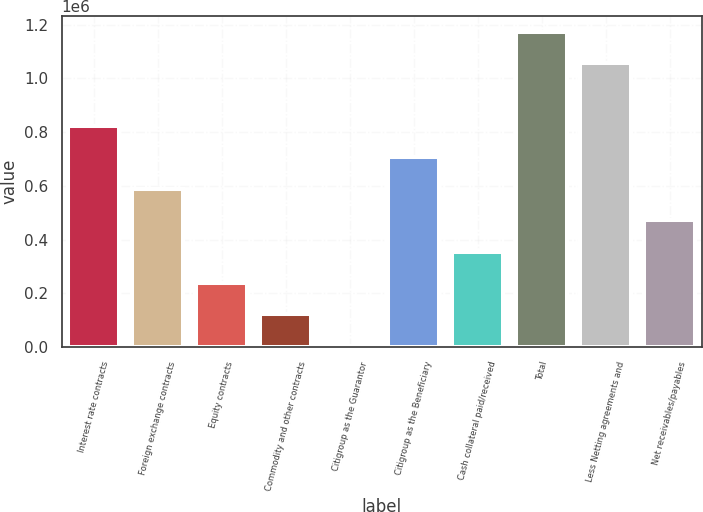Convert chart. <chart><loc_0><loc_0><loc_500><loc_500><bar_chart><fcel>Interest rate contracts<fcel>Foreign exchange contracts<fcel>Equity contracts<fcel>Commodity and other contracts<fcel>Citigroup as the Guarantor<fcel>Citigroup as the Beneficiary<fcel>Cash collateral paid/received<fcel>Total<fcel>Less Netting agreements and<fcel>Net receivables/payables<nl><fcel>822623<fcel>589271<fcel>239242<fcel>122566<fcel>5890<fcel>705947<fcel>355919<fcel>1.17404e+06<fcel>1.05736e+06<fcel>472595<nl></chart> 